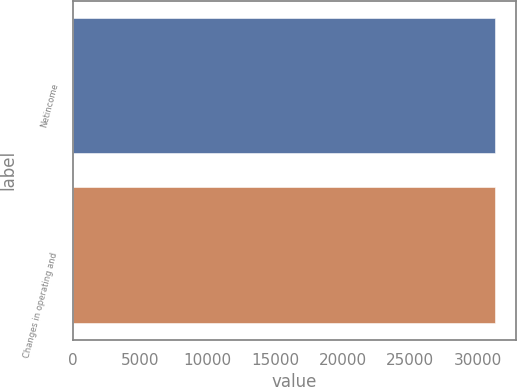<chart> <loc_0><loc_0><loc_500><loc_500><bar_chart><fcel>Netincome<fcel>Changes in operating and<nl><fcel>31257<fcel>31257.1<nl></chart> 